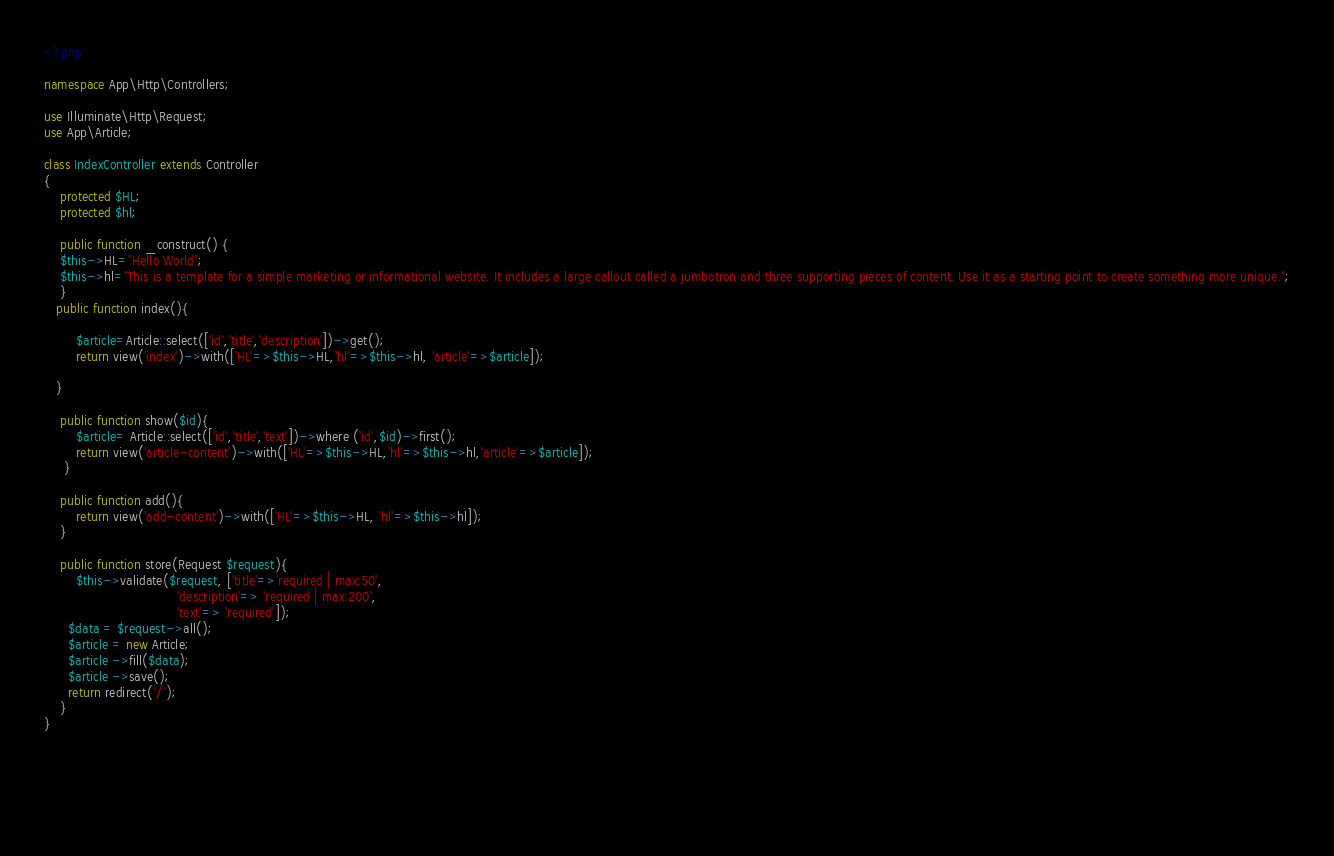<code> <loc_0><loc_0><loc_500><loc_500><_PHP_><?php

namespace App\Http\Controllers;

use Illuminate\Http\Request;
use App\Article;

class IndexController extends Controller
{ 
    protected $HL;
    protected $hl;

    public function _construct() {
    $this->HL="Hello World";
    $this->hl="This is a template for a simple marketing or informational website. It includes a large callout called a jumbotron and three supporting pieces of content. Use it as a starting point to create something more unique.";
    }
   public function index(){

        $article=Article::select(['id','title','description'])->get();
        return view('index')->with(['HL'=>$this->HL,'hl'=>$this->hl, 'article'=>$article]);

   }

    public function show($id){
        $article= Article::select(['id','title','text'])->where ('id',$id)->first();
        return view('article-content')->with(['HL'=>$this->HL,'hl'=>$this->hl,'article'=>$article]);
     }
       
    public function add(){
        return view('add-content')->with(['HL'=>$this->HL, 'hl'=>$this->hl]);
    }

    public function store(Request $request){
        $this->validate($request, ['title'=>'required | max:50',
                                 'description'=> 'required | max:200',
                                 'text'=> 'required']);
      $data = $request->all();
      $article = new Article;
      $article ->fill($data);
      $article ->save();
      return redirect('/');
    }
}

 
    

    

</code> 